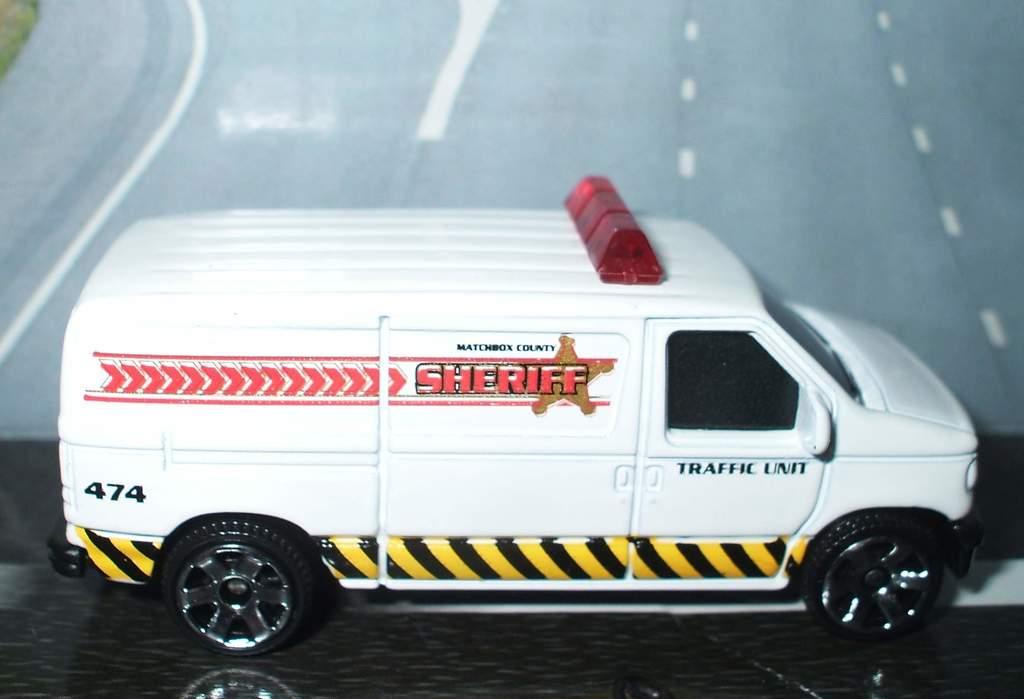What unit of the sheriff's office does the van belong to?
Your answer should be compact. Traffic. What is the van number?
Your answer should be compact. 474. 